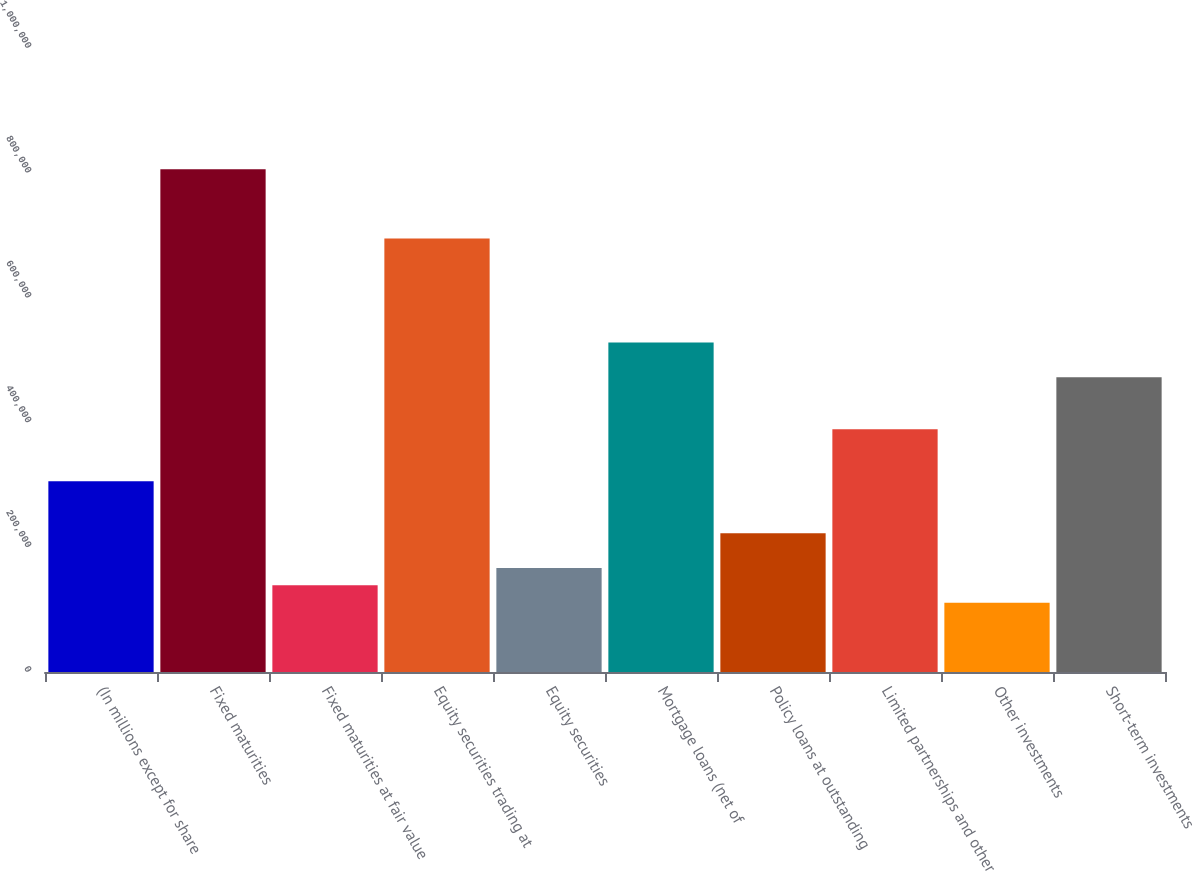Convert chart. <chart><loc_0><loc_0><loc_500><loc_500><bar_chart><fcel>(In millions except for share<fcel>Fixed maturities<fcel>Fixed maturities at fair value<fcel>Equity securities trading at<fcel>Equity securities<fcel>Mortgage loans (net of<fcel>Policy loans at outstanding<fcel>Limited partnerships and other<fcel>Other investments<fcel>Short-term investments<nl><fcel>305672<fcel>805854<fcel>138944<fcel>694702<fcel>166732<fcel>527975<fcel>222308<fcel>389036<fcel>111157<fcel>472399<nl></chart> 